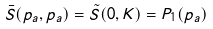<formula> <loc_0><loc_0><loc_500><loc_500>\bar { S } ( { p } _ { a } , { p } _ { a } ) = \tilde { S } ( { 0 } , { K } ) = P _ { 1 } ( { p } _ { a } )</formula> 